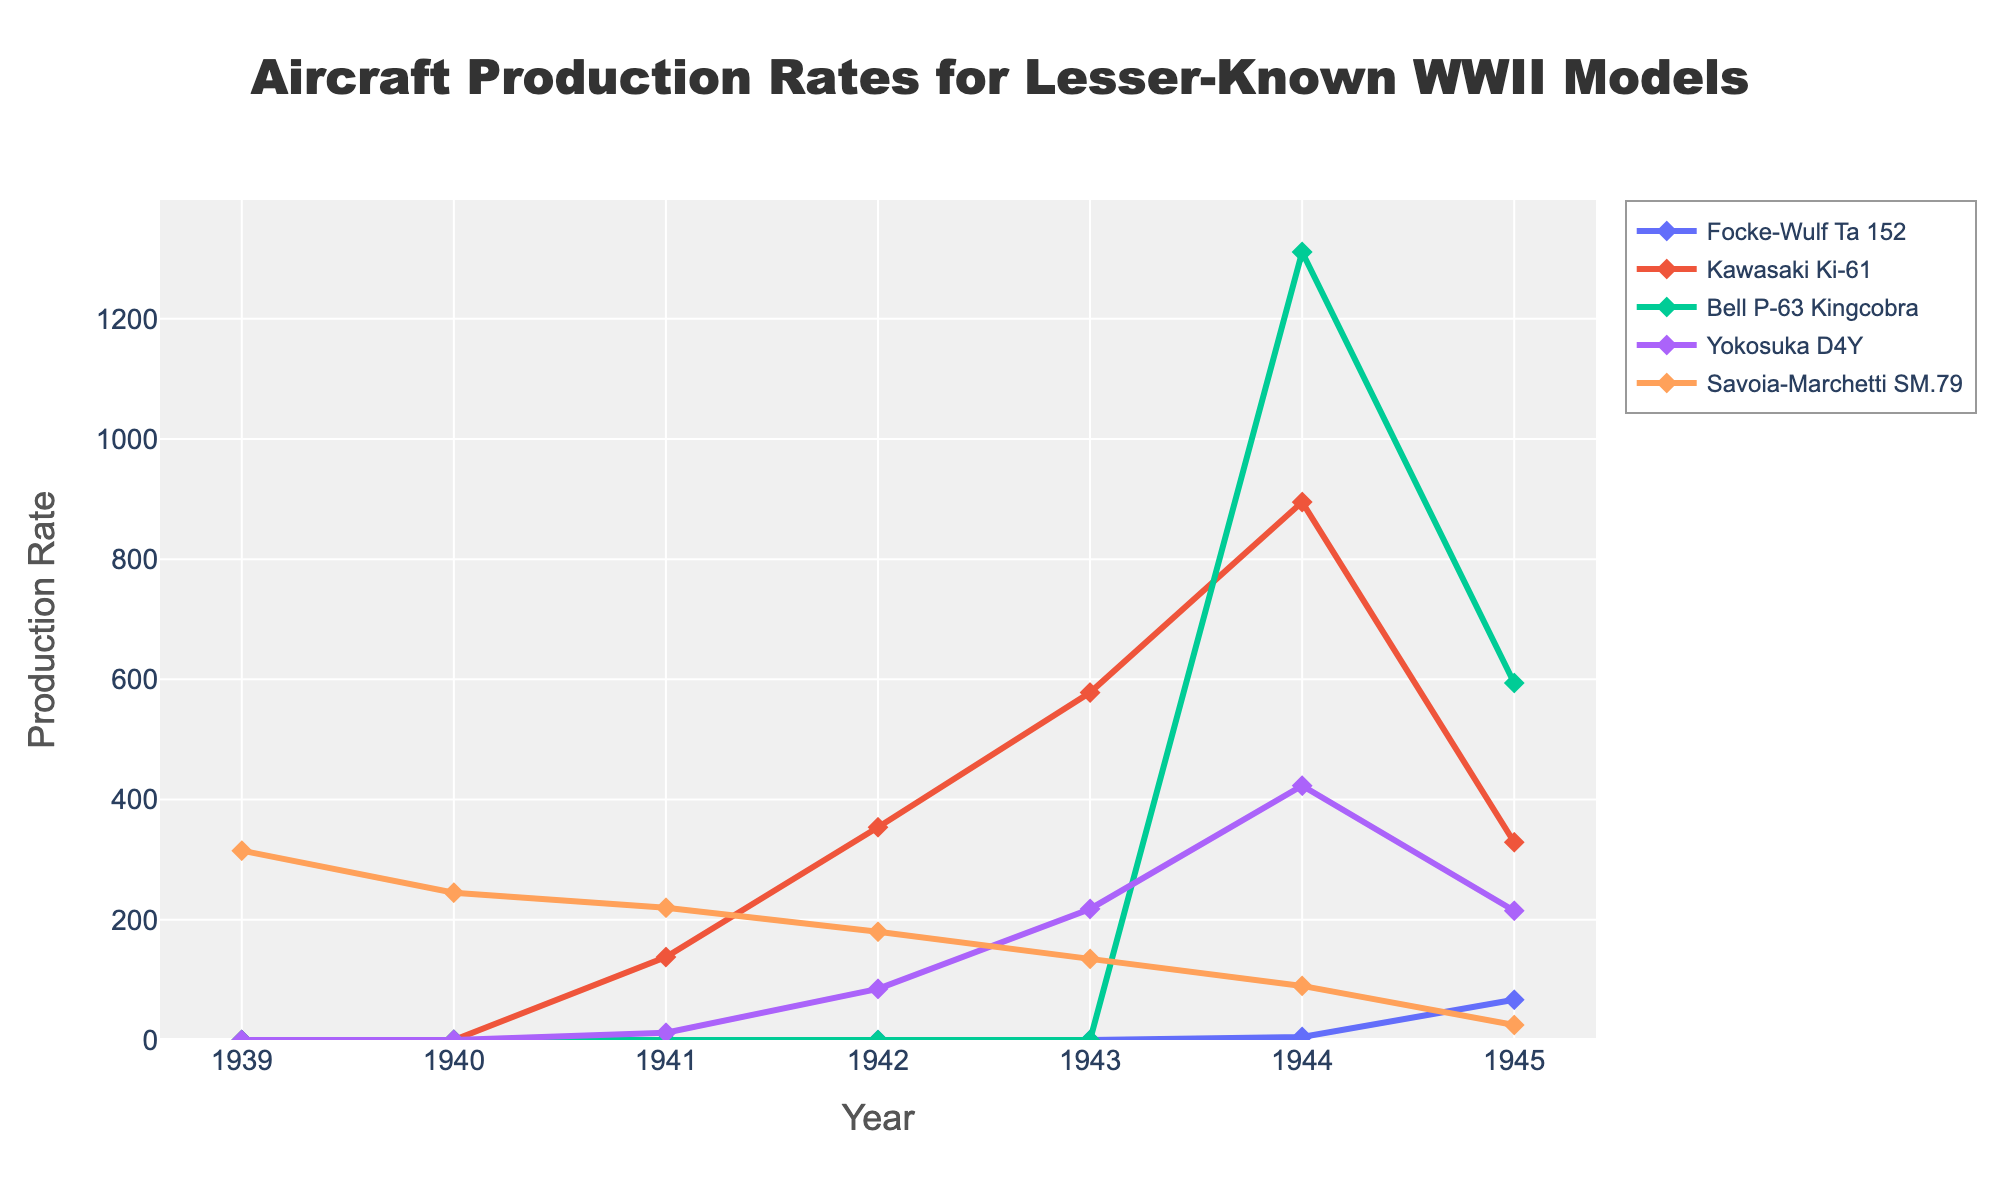When did the production rate of the Focke-Wulf Ta 152 peak? Look for the year where the Focke-Wulf Ta 152 line reaches its highest point. The peak production rate is observed in 1945.
Answer: 1945 Which aircraft had the highest production rate in 1944? Identify the lines corresponding to different aircraft models in the year 1944 and observe which one reaches the highest point. Bell P-63 Kingcobra has the highest production rate in 1944.
Answer: Bell P-63 Kingcobra What is the total production rate for the Savoia-Marchetti SM.79 over all the years? Sum the production rates of the Savoia-Marchetti SM.79 from 1939 to 1945 (315 + 245 + 220 + 180 + 135 + 90 + 25). The total is 1210.
Answer: 1210 Between 1942 and 1945, which aircraft had the greatest increase in production rate? Calculate the difference in production rates between 1942 and 1945 for each aircraft, then find the maximum value among those differences. The Bell P-63 Kingcobra increased from 0 to 594, which is an increase of 594, the largest increase.
Answer: Bell P-63 Kingcobra In which year did the Yokosuka D4Y first appear in production? Identify the first year that has a non-zero production rate for the Yokosuka D4Y. The first appearance is in 1941.
Answer: 1941 By how much did the production rate of the Kawasaki Ki-61 change from 1943 to 1944? Subtract the production rate of the Kawasaki Ki-61 in 1943 from its rate in 1944 (895 - 578). The change is 317.
Answer: 317 Which two aircraft had production rates close to each other in 1945, and what are those rates? Compare the production rates of different aircraft in the year 1945. The Focke-Wulf Ta 152 and Yokosuka D4Y had production rates that are close: 67 and 215.
Answer: Focke-Wulf Ta 152 (67) and Yokosuka D4Y (215) What is the average annual production rate of the Bell P-63 Kingcobra from 1944 to 1945? Sum the production rates for the Bell P-63 Kingcobra in 1944 and 1945 and divide by the number of years (1311 + 594) / 2. The average is 952.5.
Answer: 952.5 Which aircraft showed a declining production rate after 1943, and what might be the cause of that decline? Identify the aircraft with a decreasing production rate post-1943. Savoia-Marchetti SM.79 shows a decline. Potential causes could include changing war conditions or strategic shifts.
Answer: Savoia-Marchetti SM.79 How does the production rate of the Kawasaki Ki-61 in 1942 compare to 1941? Compare the production rates of the Kawasaki Ki-61 in 1942 and 1941. It increased from 138 to 354. Thus, there is an increase.
Answer: Increased 